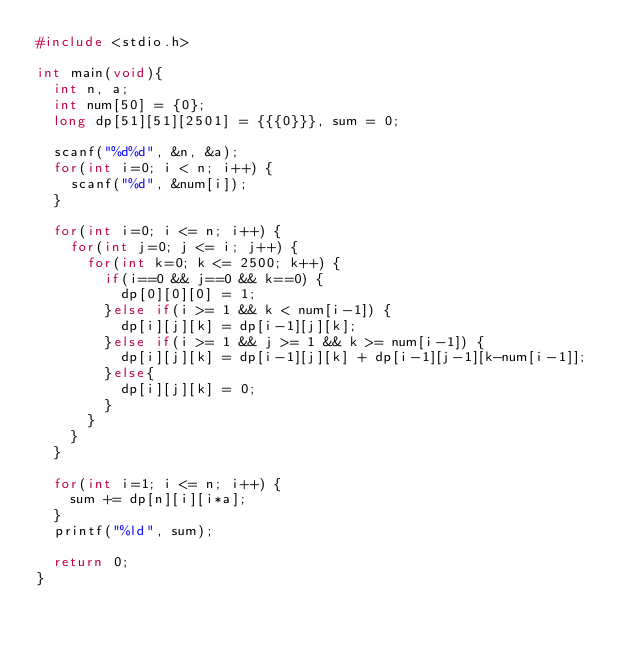<code> <loc_0><loc_0><loc_500><loc_500><_C_>#include <stdio.h>

int main(void){
	int n, a;
	int num[50] = {0};
	long dp[51][51][2501] = {{{0}}}, sum = 0;

	scanf("%d%d", &n, &a);
	for(int i=0; i < n; i++) {
		scanf("%d", &num[i]);
	}

	for(int i=0; i <= n; i++) {
		for(int j=0; j <= i; j++) {
			for(int k=0; k <= 2500; k++) {
				if(i==0 && j==0 && k==0) {
					dp[0][0][0] = 1;
				}else if(i >= 1 && k < num[i-1]) {
					dp[i][j][k] = dp[i-1][j][k];
				}else if(i >= 1 && j >= 1 && k >= num[i-1]) {
					dp[i][j][k] = dp[i-1][j][k] + dp[i-1][j-1][k-num[i-1]];
				}else{
					dp[i][j][k] = 0;
				}
			}
		}
	}

	for(int i=1; i <= n; i++) {
		sum += dp[n][i][i*a];
	}
	printf("%ld", sum);

	return 0;
}
</code> 